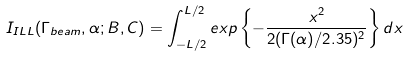Convert formula to latex. <formula><loc_0><loc_0><loc_500><loc_500>I _ { I L L } ( \Gamma _ { b e a m } , \alpha ; B , C ) = \int _ { - L / 2 } ^ { L / 2 } e x p \left \{ - \frac { x ^ { 2 } } { 2 ( \Gamma ( \alpha ) / 2 . 3 5 ) ^ { 2 } } \right \} d x</formula> 